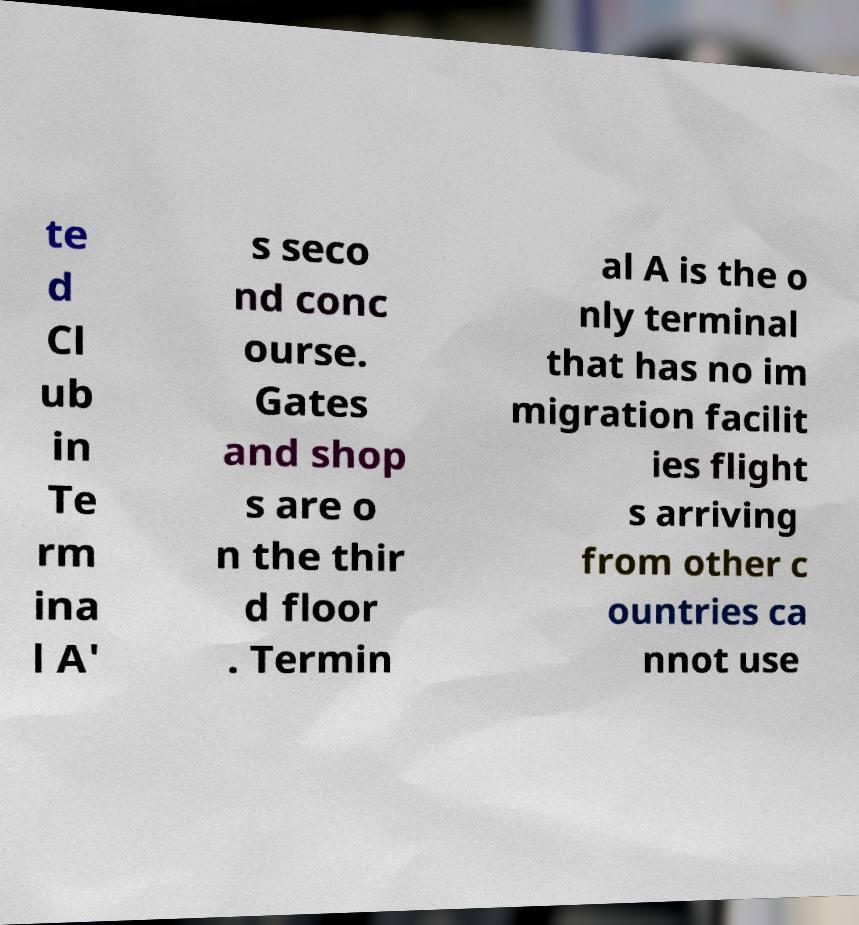I need the written content from this picture converted into text. Can you do that? te d Cl ub in Te rm ina l A' s seco nd conc ourse. Gates and shop s are o n the thir d floor . Termin al A is the o nly terminal that has no im migration facilit ies flight s arriving from other c ountries ca nnot use 